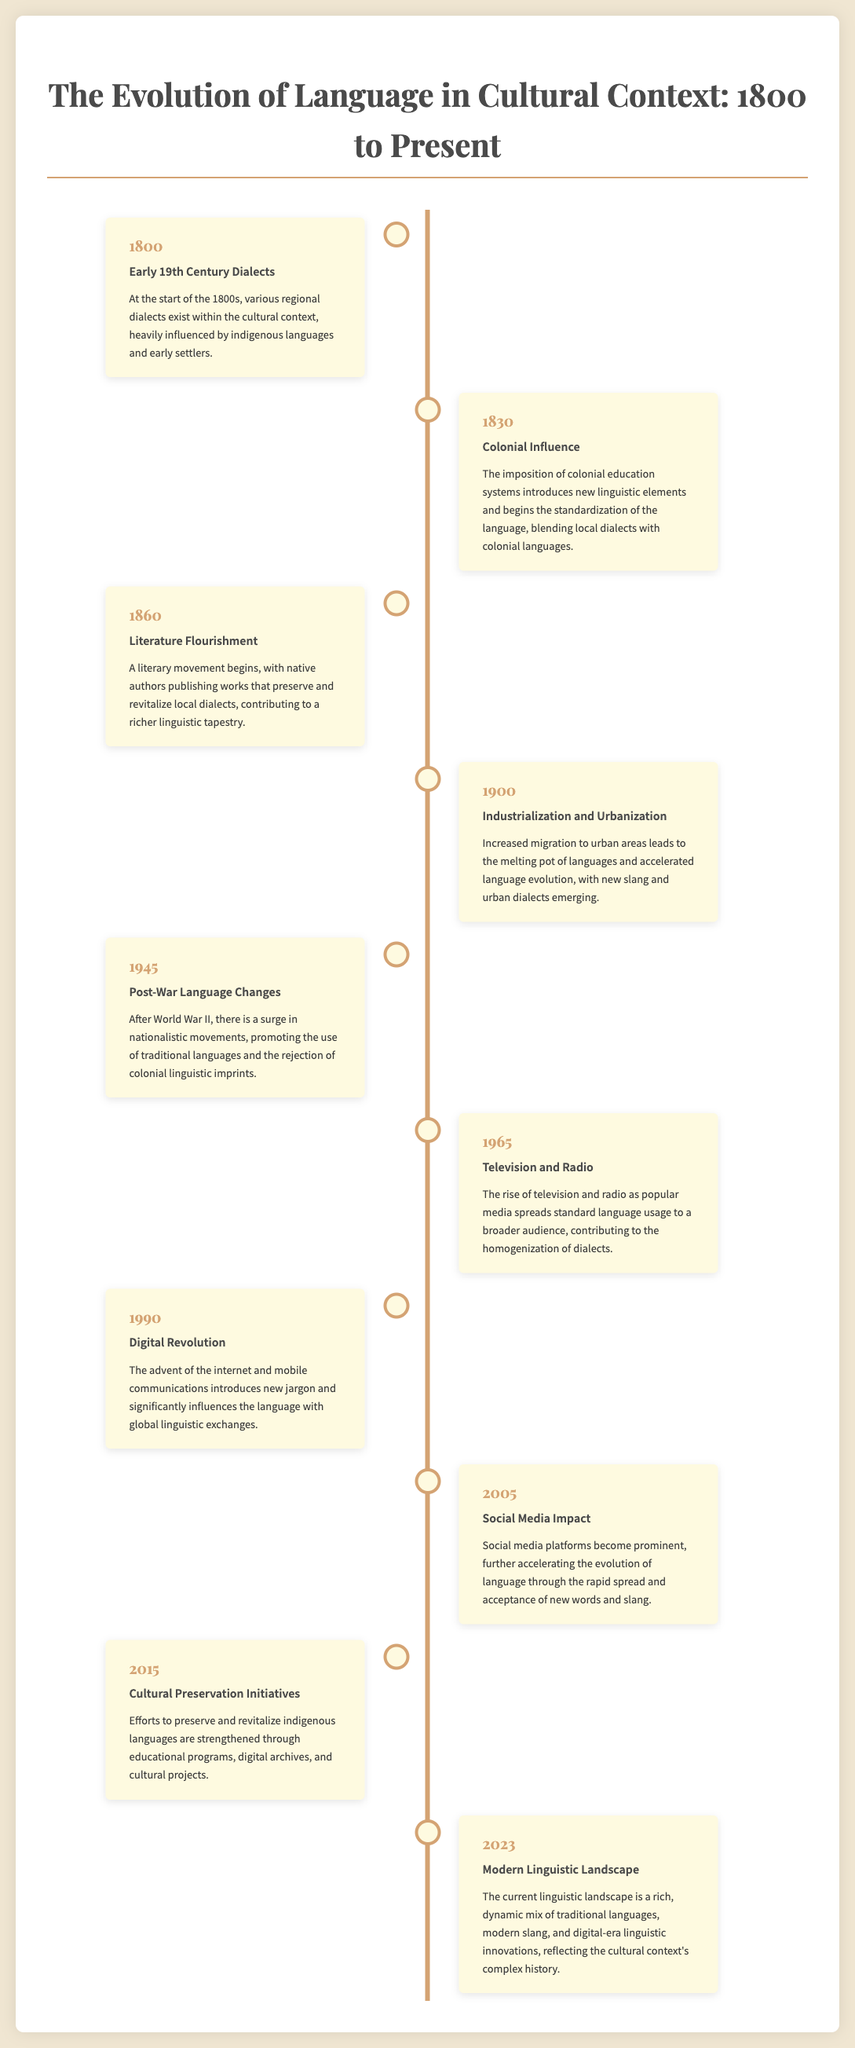what was the event in 1830? The event in 1830 was the imposition of colonial education systems, which introduces new linguistic elements.
Answer: Colonial Influence what year marked the start of the literary movement? The literary movement began in the year 1860.
Answer: 1860 what significant change occurred in 1900? In 1900, increased migration to urban areas led to a melting pot of languages.
Answer: Industrialization and Urbanization which year saw the rise of television and radio? The rise of television and radio occurred in 1965.
Answer: 1965 what is a key feature of the linguistic landscape in 2023? The current linguistic landscape is a rich, dynamic mix of traditional languages.
Answer: Modern Linguistic Landscape what cultural initiatives were strengthened in 2015? In 2015, efforts were strengthened to preserve and revitalize indigenous languages.
Answer: Cultural Preservation Initiatives which event reflects the rejection of colonial linguistic imprints? The event reflecting the rejection of colonial linguistic imprints is the surge in nationalistic movements.
Answer: Post-War Language Changes how did the digital revolution affect language? The digital revolution introduced new jargon and significantly influenced the language.
Answer: Digital Revolution what was the focus of literature during 1860? The focus of literature during 1860 was to preserve and revitalize local dialects.
Answer: Literature Flourishment 